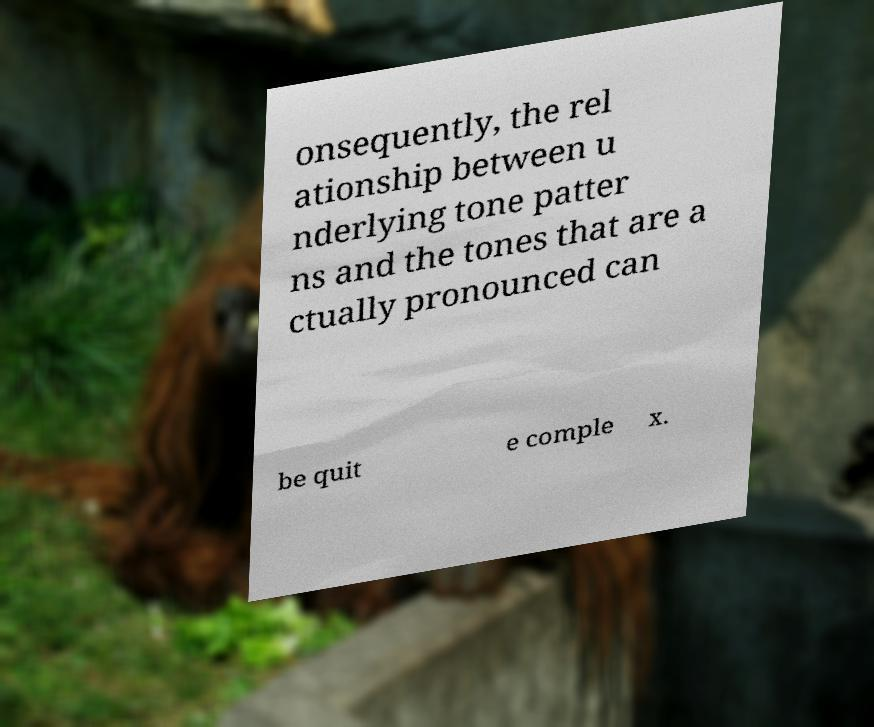I need the written content from this picture converted into text. Can you do that? onsequently, the rel ationship between u nderlying tone patter ns and the tones that are a ctually pronounced can be quit e comple x. 